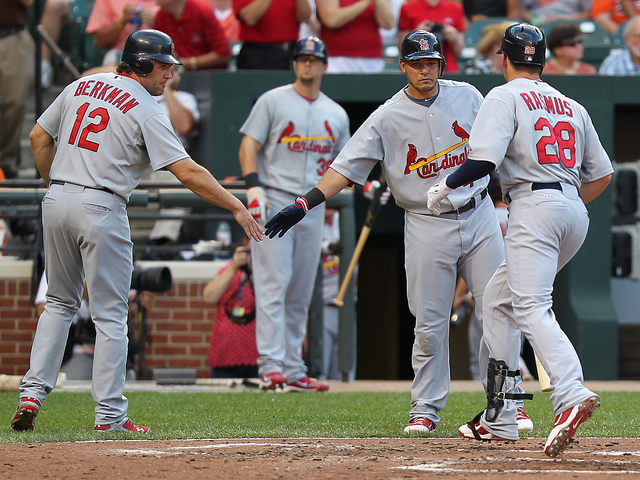Read all the text in this image. BERKMAN 12 RASMUS 28 Cardinals 3 Cardinals 